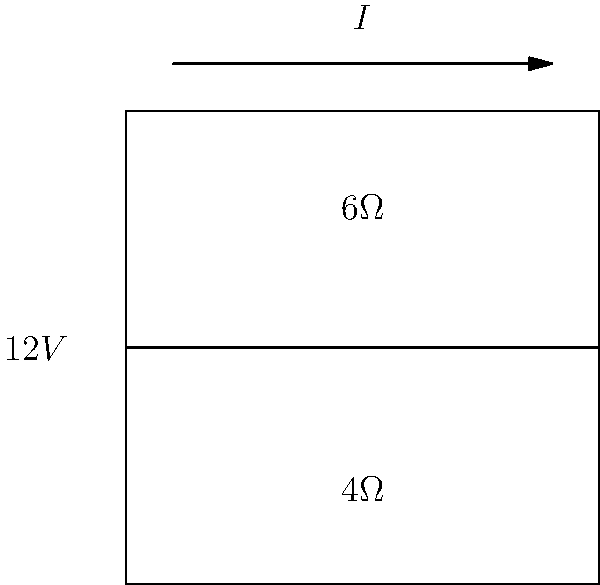In this series circuit inspired by the rhythmic flow of Loretta Heywood's music, a $12V$ source powers two resistors: $6\Omega$ and $4\Omega$. What is the voltage drop across the $4\Omega$ resistor? Let's approach this step-by-step, much like composing a song:

1) First, we need to find the total resistance in the circuit:
   $R_{total} = R_1 + R_2 = 6\Omega + 4\Omega = 10\Omega$

2) Now, we can calculate the current in the circuit using Ohm's Law:
   $I = \frac{V}{R_{total}} = \frac{12V}{10\Omega} = 1.2A$

3) The voltage drop across a resistor is given by Ohm's Law: $V = IR$

4) For the $4\Omega$ resistor:
   $V_{4\Omega} = I \times 4\Omega = 1.2A \times 4\Omega = 4.8V$

Just as each note in a Loretta Heywood song contributes to the overall melody, each component in this circuit plays its part in the voltage distribution.
Answer: $4.8V$ 